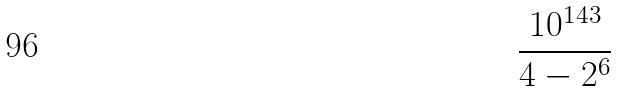Convert formula to latex. <formula><loc_0><loc_0><loc_500><loc_500>\frac { 1 0 ^ { 1 4 3 } } { 4 - 2 ^ { 6 } }</formula> 